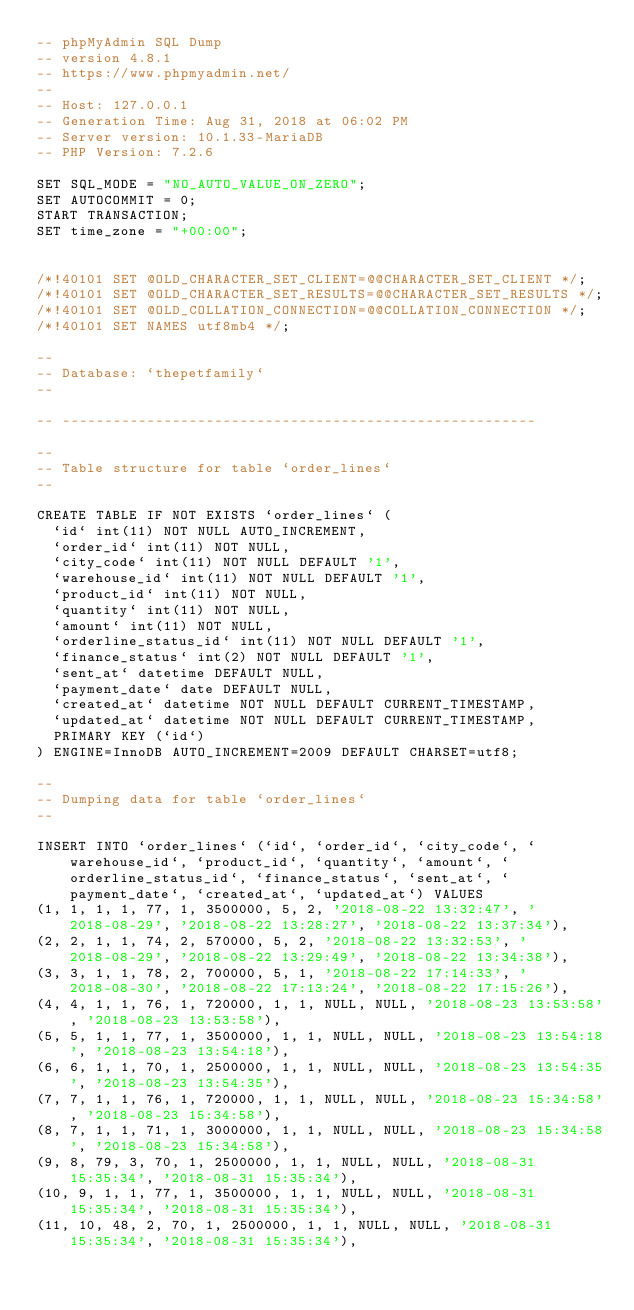<code> <loc_0><loc_0><loc_500><loc_500><_SQL_>-- phpMyAdmin SQL Dump
-- version 4.8.1
-- https://www.phpmyadmin.net/
--
-- Host: 127.0.0.1
-- Generation Time: Aug 31, 2018 at 06:02 PM
-- Server version: 10.1.33-MariaDB
-- PHP Version: 7.2.6

SET SQL_MODE = "NO_AUTO_VALUE_ON_ZERO";
SET AUTOCOMMIT = 0;
START TRANSACTION;
SET time_zone = "+00:00";


/*!40101 SET @OLD_CHARACTER_SET_CLIENT=@@CHARACTER_SET_CLIENT */;
/*!40101 SET @OLD_CHARACTER_SET_RESULTS=@@CHARACTER_SET_RESULTS */;
/*!40101 SET @OLD_COLLATION_CONNECTION=@@COLLATION_CONNECTION */;
/*!40101 SET NAMES utf8mb4 */;

--
-- Database: `thepetfamily`
--

-- --------------------------------------------------------

--
-- Table structure for table `order_lines`
--

CREATE TABLE IF NOT EXISTS `order_lines` (
  `id` int(11) NOT NULL AUTO_INCREMENT,
  `order_id` int(11) NOT NULL,
  `city_code` int(11) NOT NULL DEFAULT '1',
  `warehouse_id` int(11) NOT NULL DEFAULT '1',
  `product_id` int(11) NOT NULL,
  `quantity` int(11) NOT NULL,
  `amount` int(11) NOT NULL,
  `orderline_status_id` int(11) NOT NULL DEFAULT '1',
  `finance_status` int(2) NOT NULL DEFAULT '1',
  `sent_at` datetime DEFAULT NULL,
  `payment_date` date DEFAULT NULL,
  `created_at` datetime NOT NULL DEFAULT CURRENT_TIMESTAMP,
  `updated_at` datetime NOT NULL DEFAULT CURRENT_TIMESTAMP,
  PRIMARY KEY (`id`)
) ENGINE=InnoDB AUTO_INCREMENT=2009 DEFAULT CHARSET=utf8;

--
-- Dumping data for table `order_lines`
--

INSERT INTO `order_lines` (`id`, `order_id`, `city_code`, `warehouse_id`, `product_id`, `quantity`, `amount`, `orderline_status_id`, `finance_status`, `sent_at`, `payment_date`, `created_at`, `updated_at`) VALUES
(1, 1, 1, 1, 77, 1, 3500000, 5, 2, '2018-08-22 13:32:47', '2018-08-29', '2018-08-22 13:28:27', '2018-08-22 13:37:34'),
(2, 2, 1, 1, 74, 2, 570000, 5, 2, '2018-08-22 13:32:53', '2018-08-29', '2018-08-22 13:29:49', '2018-08-22 13:34:38'),
(3, 3, 1, 1, 78, 2, 700000, 5, 1, '2018-08-22 17:14:33', '2018-08-30', '2018-08-22 17:13:24', '2018-08-22 17:15:26'),
(4, 4, 1, 1, 76, 1, 720000, 1, 1, NULL, NULL, '2018-08-23 13:53:58', '2018-08-23 13:53:58'),
(5, 5, 1, 1, 77, 1, 3500000, 1, 1, NULL, NULL, '2018-08-23 13:54:18', '2018-08-23 13:54:18'),
(6, 6, 1, 1, 70, 1, 2500000, 1, 1, NULL, NULL, '2018-08-23 13:54:35', '2018-08-23 13:54:35'),
(7, 7, 1, 1, 76, 1, 720000, 1, 1, NULL, NULL, '2018-08-23 15:34:58', '2018-08-23 15:34:58'),
(8, 7, 1, 1, 71, 1, 3000000, 1, 1, NULL, NULL, '2018-08-23 15:34:58', '2018-08-23 15:34:58'),
(9, 8, 79, 3, 70, 1, 2500000, 1, 1, NULL, NULL, '2018-08-31 15:35:34', '2018-08-31 15:35:34'),
(10, 9, 1, 1, 77, 1, 3500000, 1, 1, NULL, NULL, '2018-08-31 15:35:34', '2018-08-31 15:35:34'),
(11, 10, 48, 2, 70, 1, 2500000, 1, 1, NULL, NULL, '2018-08-31 15:35:34', '2018-08-31 15:35:34'),</code> 